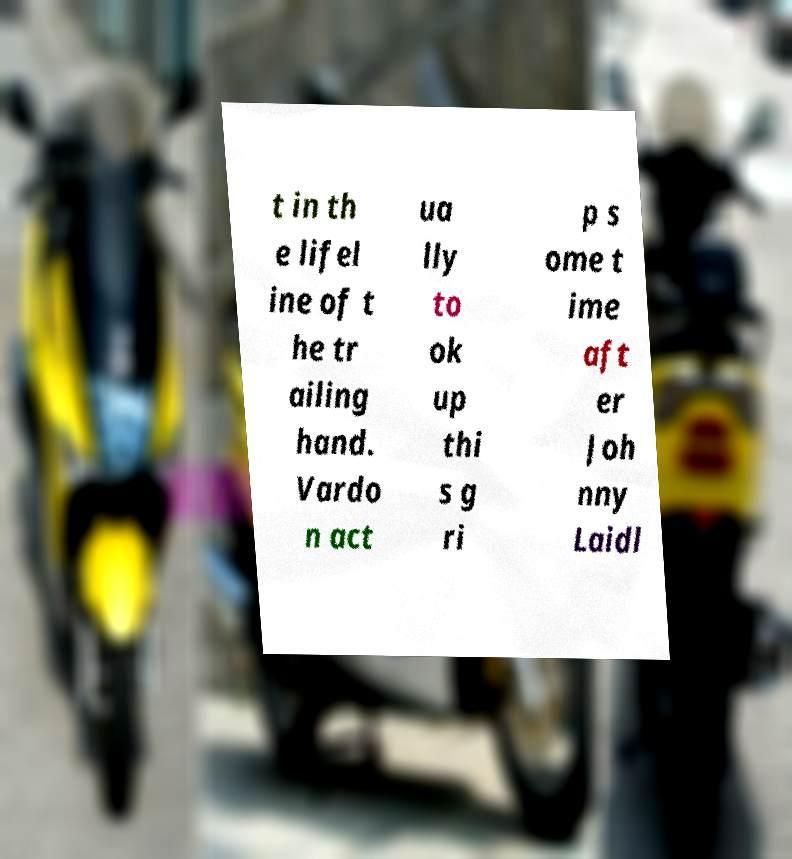What messages or text are displayed in this image? I need them in a readable, typed format. t in th e lifel ine of t he tr ailing hand. Vardo n act ua lly to ok up thi s g ri p s ome t ime aft er Joh nny Laidl 